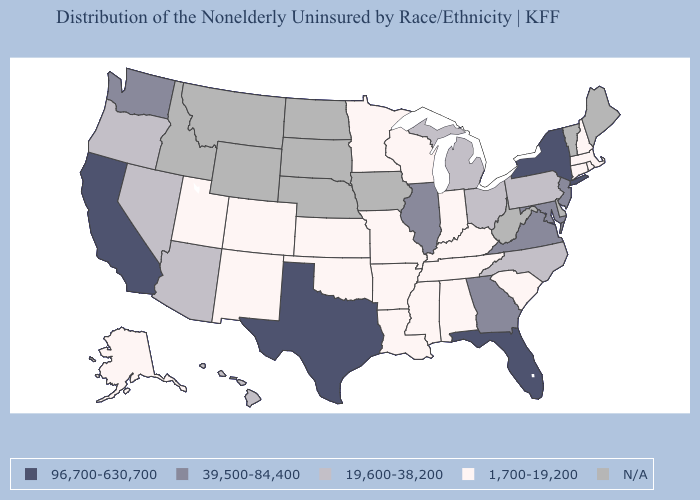Does Virginia have the lowest value in the USA?
Write a very short answer. No. What is the lowest value in the Northeast?
Keep it brief. 1,700-19,200. What is the value of New Hampshire?
Quick response, please. 1,700-19,200. Which states have the highest value in the USA?
Write a very short answer. California, Florida, New York, Texas. What is the highest value in the USA?
Write a very short answer. 96,700-630,700. What is the value of Montana?
Write a very short answer. N/A. Among the states that border Colorado , does Arizona have the lowest value?
Give a very brief answer. No. Among the states that border South Carolina , which have the highest value?
Short answer required. Georgia. What is the value of New Mexico?
Short answer required. 1,700-19,200. Among the states that border Pennsylvania , which have the lowest value?
Keep it brief. Ohio. What is the value of Florida?
Be succinct. 96,700-630,700. Name the states that have a value in the range 1,700-19,200?
Keep it brief. Alabama, Alaska, Arkansas, Colorado, Connecticut, Indiana, Kansas, Kentucky, Louisiana, Massachusetts, Minnesota, Mississippi, Missouri, New Hampshire, New Mexico, Oklahoma, Rhode Island, South Carolina, Tennessee, Utah, Wisconsin. What is the value of New Hampshire?
Quick response, please. 1,700-19,200. Does the map have missing data?
Keep it brief. Yes. 